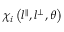<formula> <loc_0><loc_0><loc_500><loc_500>\chi _ { i } \left ( l ^ { \| } , l ^ { \perp } , \theta \right )</formula> 